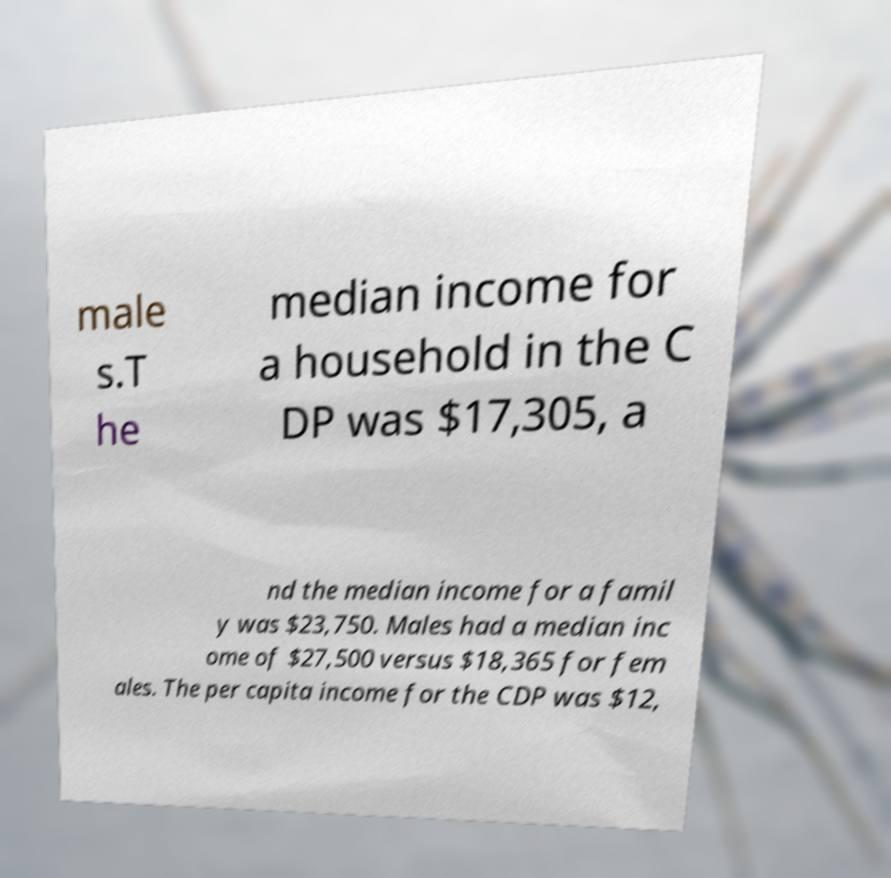Please read and relay the text visible in this image. What does it say? male s.T he median income for a household in the C DP was $17,305, a nd the median income for a famil y was $23,750. Males had a median inc ome of $27,500 versus $18,365 for fem ales. The per capita income for the CDP was $12, 